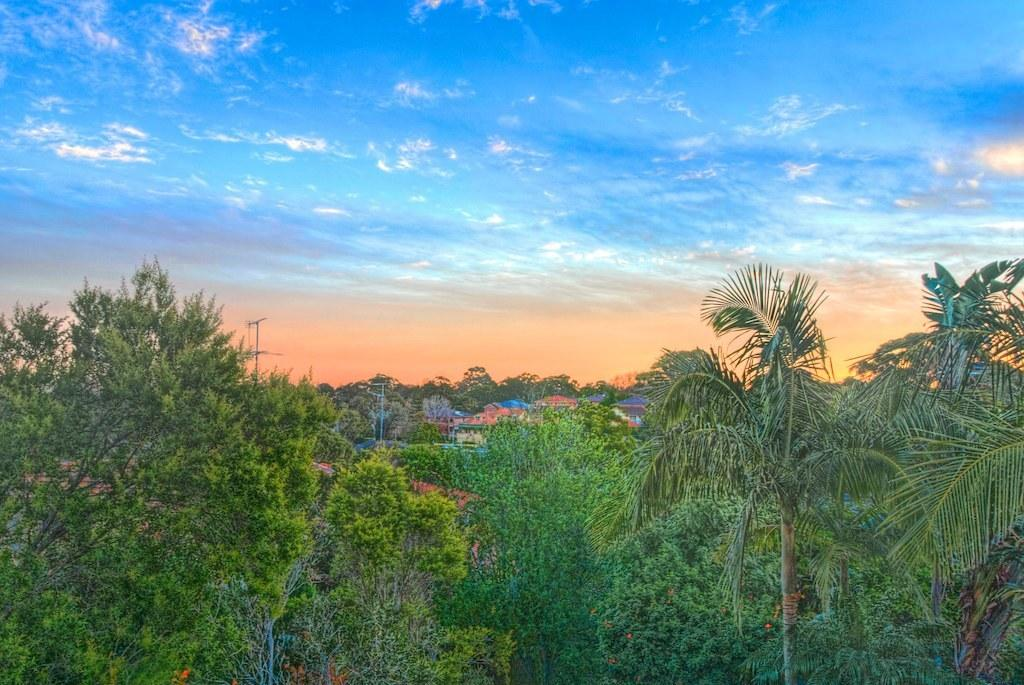What type of vegetation can be seen at the bottom of the image? There are trees visible at the bottom of the image. What structures are present in the middle of the image? There are poles in the middle of the image. What else might be visible in the middle of the image besides poles? There might be houses and trees visible in the middle of the image. What is visible at the top of the image? The sky is visible at the top of the image. What is the average income of the people swimming in the image? There is no swimming or people visible in the image, so it is not possible to determine their income. How often do the trees wash themselves in the image? Trees do not wash themselves, so this question cannot be answered based on the image. 